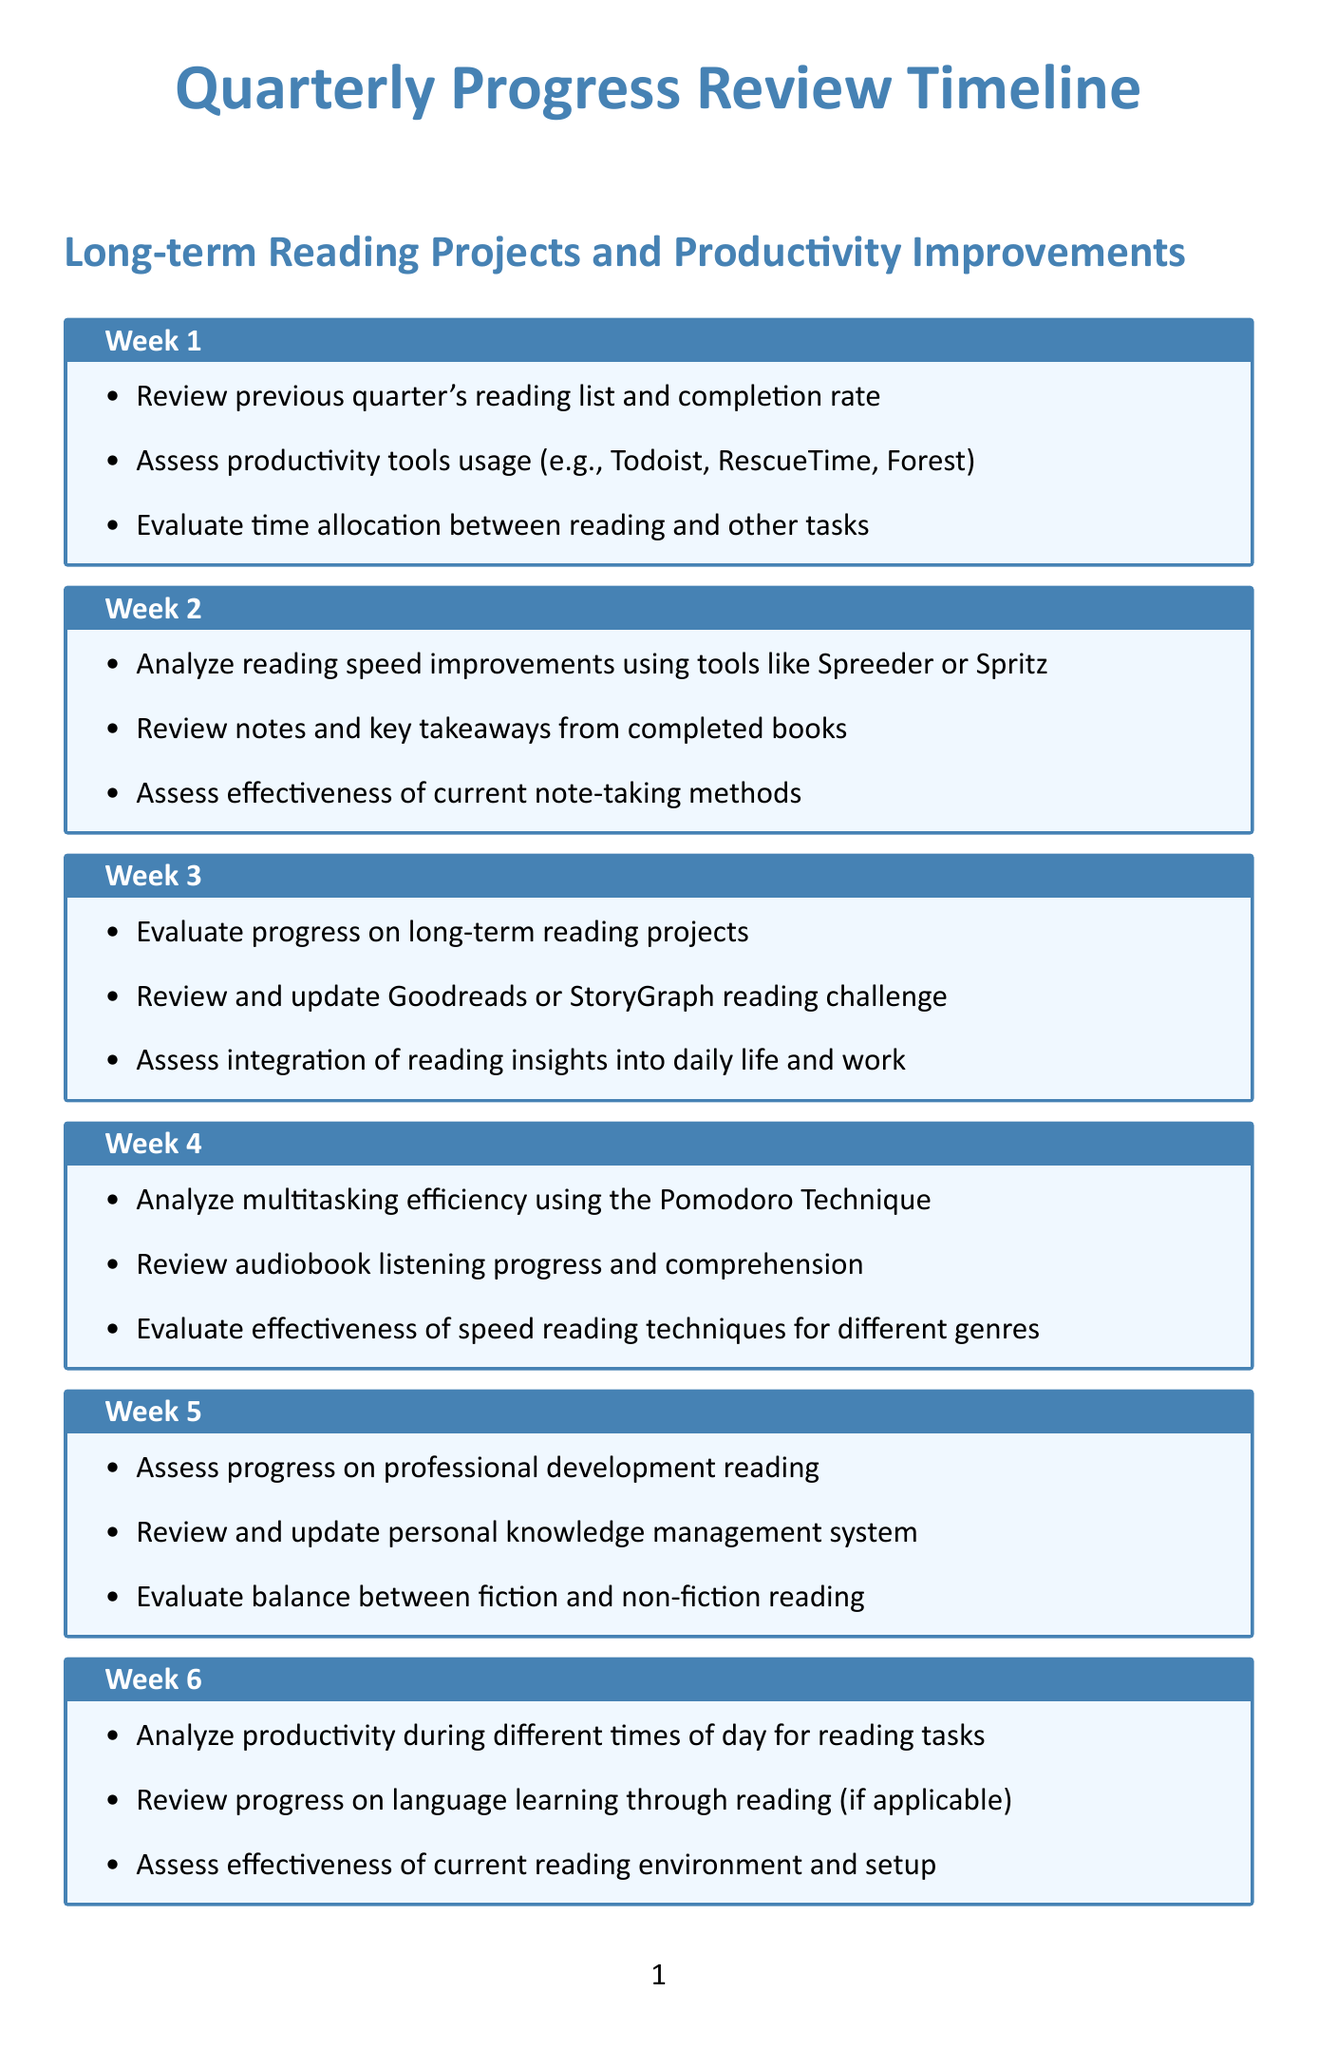What is the focus of week 1 activities? Week 1 activities focus on reviewing the previous quarter's reading list and completion rate.
Answer: Previous quarter's reading list and completion rate What is the main assessment in week 2? In week 2, the main assessment is of reading speed improvements using various tools.
Answer: Reading speed improvements What type of reading is evaluated in week 5? Week 5 evaluates progress on professional development reading materials.
Answer: Professional development reading How many weeks are included in the quarterly review schedule? The document outlines activities for a total of 12 weeks.
Answer: 12 What specific technique is analyzed in week 4? Week 4 specifically analyzes multitasking efficiency using the Pomodoro Technique.
Answer: Pomodoro Technique What is the purpose of week 8 activities? The purpose of week 8 activities is to analyze retention and application of knowledge from read materials.
Answer: Retention and application of knowledge What is assessed regarding reading habits in week 7? In week 7, the impact of reading habits on sleep patterns and overall well-being is assessed.
Answer: Impact on sleep patterns and well-being What is the final activity in week 12? The final activity in week 12 involves setting new reading and productivity goals for the next quarter.
Answer: Setting new reading and productivity goals 